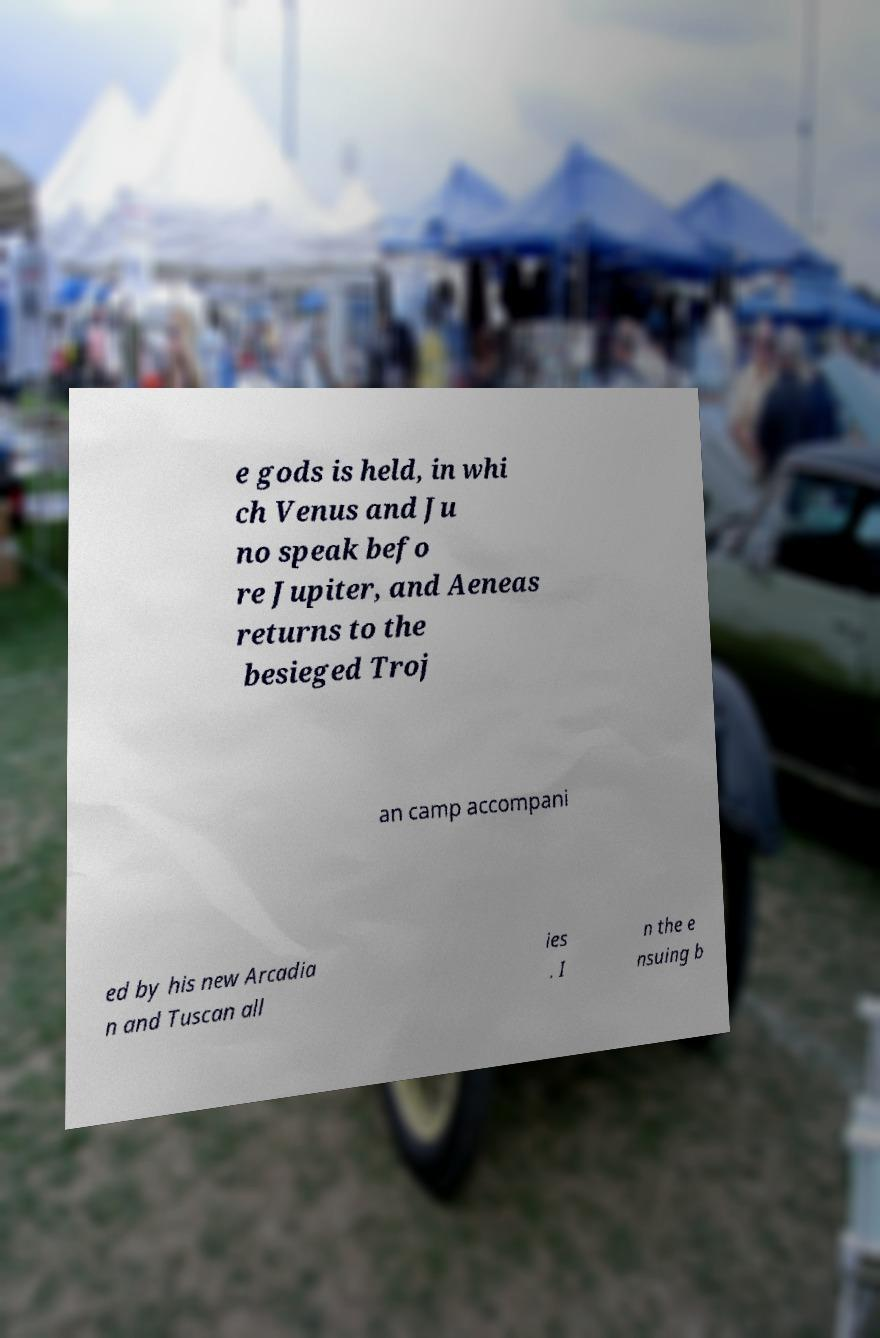Could you extract and type out the text from this image? e gods is held, in whi ch Venus and Ju no speak befo re Jupiter, and Aeneas returns to the besieged Troj an camp accompani ed by his new Arcadia n and Tuscan all ies . I n the e nsuing b 